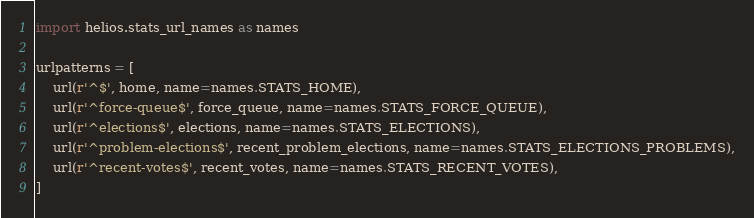<code> <loc_0><loc_0><loc_500><loc_500><_Python_>import helios.stats_url_names as names

urlpatterns = [
    url(r'^$', home, name=names.STATS_HOME),
    url(r'^force-queue$', force_queue, name=names.STATS_FORCE_QUEUE),
    url(r'^elections$', elections, name=names.STATS_ELECTIONS),
    url(r'^problem-elections$', recent_problem_elections, name=names.STATS_ELECTIONS_PROBLEMS),
    url(r'^recent-votes$', recent_votes, name=names.STATS_RECENT_VOTES),
]
</code> 